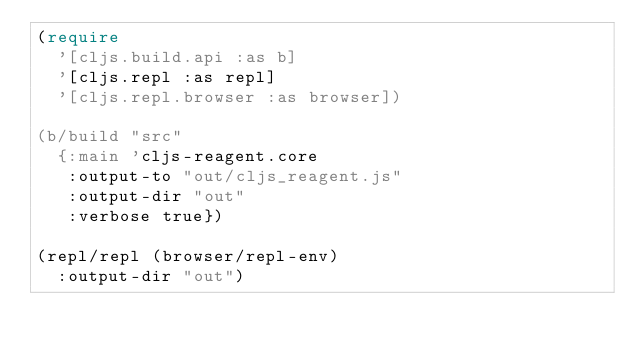<code> <loc_0><loc_0><loc_500><loc_500><_Clojure_>(require
  '[cljs.build.api :as b]
  '[cljs.repl :as repl]
  '[cljs.repl.browser :as browser])

(b/build "src"
  {:main 'cljs-reagent.core
   :output-to "out/cljs_reagent.js"
   :output-dir "out"
   :verbose true})

(repl/repl (browser/repl-env)
  :output-dir "out")
</code> 